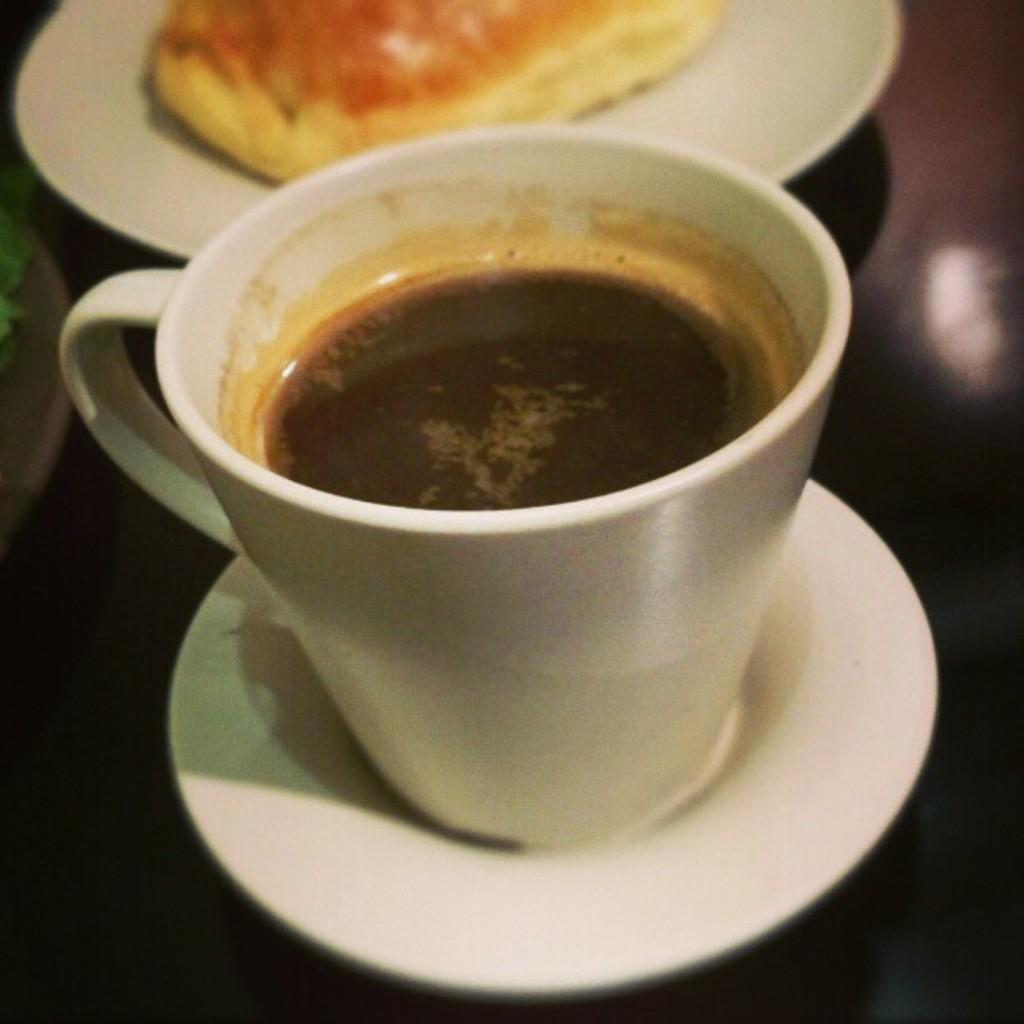What piece of furniture is present in the image? There is a table in the image. What is placed on the table? There is a plate, a cup, a saucer, and a snack item on the table. What is inside the cup or saucer? There is tea in the cup or saucer. What type of creature is holding the balloon at the party in the image? There is no party, balloon, or creature present in the image. 